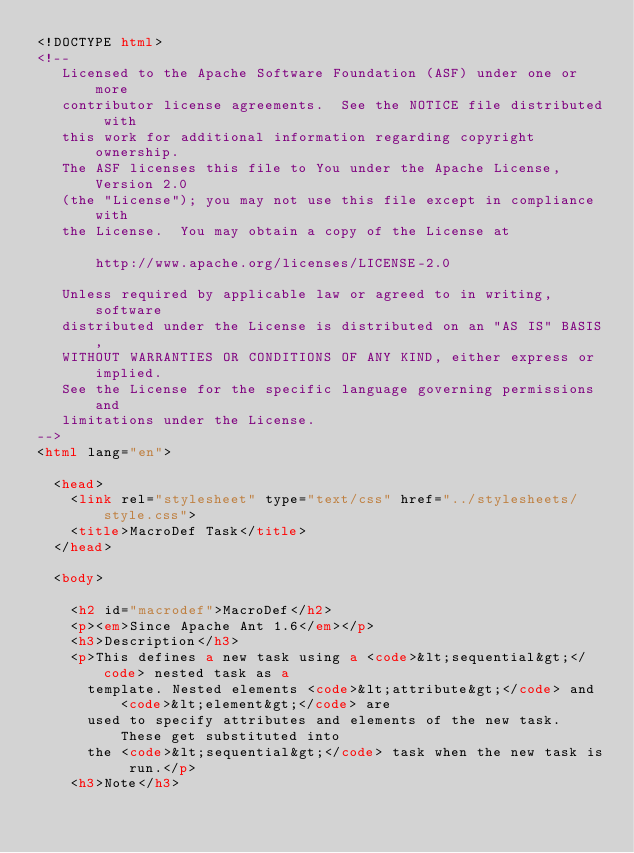<code> <loc_0><loc_0><loc_500><loc_500><_HTML_><!DOCTYPE html>
<!--
   Licensed to the Apache Software Foundation (ASF) under one or more
   contributor license agreements.  See the NOTICE file distributed with
   this work for additional information regarding copyright ownership.
   The ASF licenses this file to You under the Apache License, Version 2.0
   (the "License"); you may not use this file except in compliance with
   the License.  You may obtain a copy of the License at

       http://www.apache.org/licenses/LICENSE-2.0

   Unless required by applicable law or agreed to in writing, software
   distributed under the License is distributed on an "AS IS" BASIS,
   WITHOUT WARRANTIES OR CONDITIONS OF ANY KIND, either express or implied.
   See the License for the specific language governing permissions and
   limitations under the License.
-->
<html lang="en">

  <head>
    <link rel="stylesheet" type="text/css" href="../stylesheets/style.css">
    <title>MacroDef Task</title>
  </head>

  <body>

    <h2 id="macrodef">MacroDef</h2>
    <p><em>Since Apache Ant 1.6</em></p>
    <h3>Description</h3>
    <p>This defines a new task using a <code>&lt;sequential&gt;</code> nested task as a
      template. Nested elements <code>&lt;attribute&gt;</code> and <code>&lt;element&gt;</code> are
      used to specify attributes and elements of the new task. These get substituted into
      the <code>&lt;sequential&gt;</code> task when the new task is run.</p>
    <h3>Note</h3></code> 